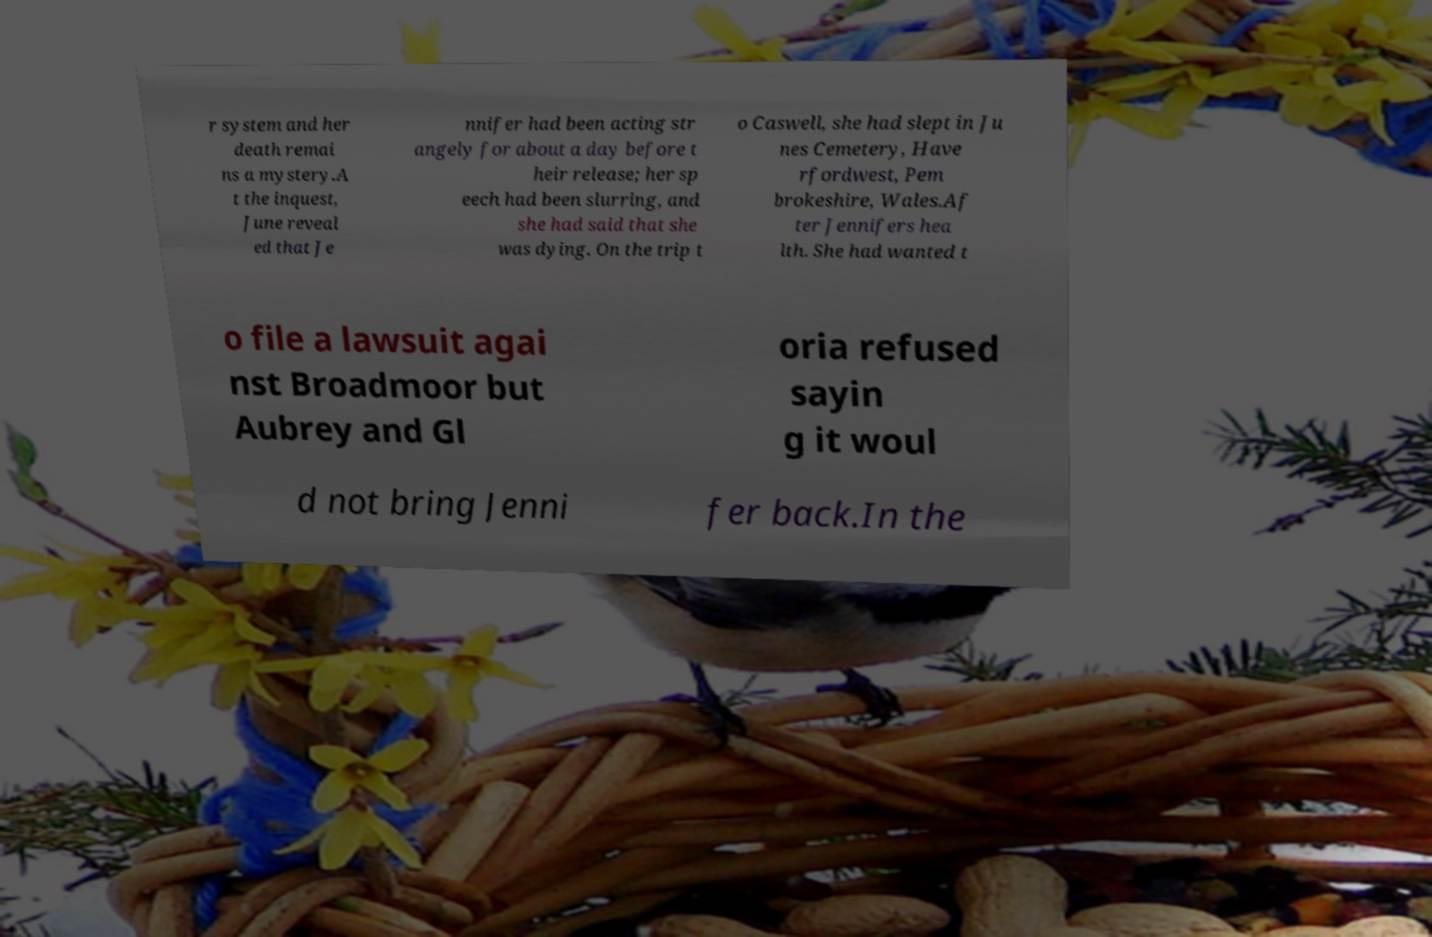Can you read and provide the text displayed in the image?This photo seems to have some interesting text. Can you extract and type it out for me? r system and her death remai ns a mystery.A t the inquest, June reveal ed that Je nnifer had been acting str angely for about a day before t heir release; her sp eech had been slurring, and she had said that she was dying. On the trip t o Caswell, she had slept in Ju nes Cemetery, Have rfordwest, Pem brokeshire, Wales.Af ter Jennifers hea lth. She had wanted t o file a lawsuit agai nst Broadmoor but Aubrey and Gl oria refused sayin g it woul d not bring Jenni fer back.In the 